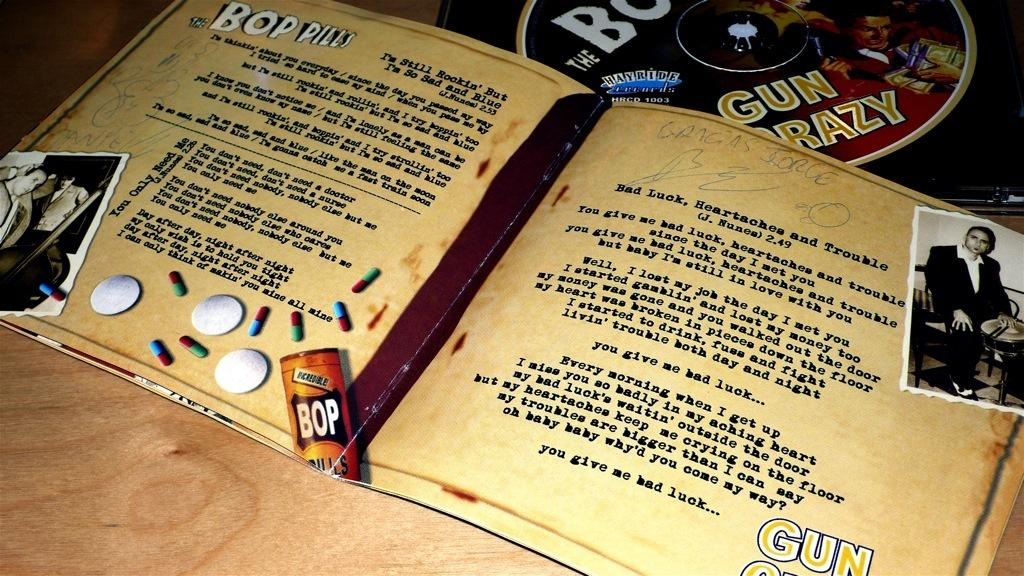What type of surface is visible in the image? There is a wooden surface in the image. What objects are placed on the wooden surface? There is a book and a compact disc on the wooden surface. Can you describe the people in the image? Unfortunately, the provided facts do not mention any details about the people in the image. What color is the balloon held by the person in the image? There is no balloon present in the image, so it is not possible to answer that question. 